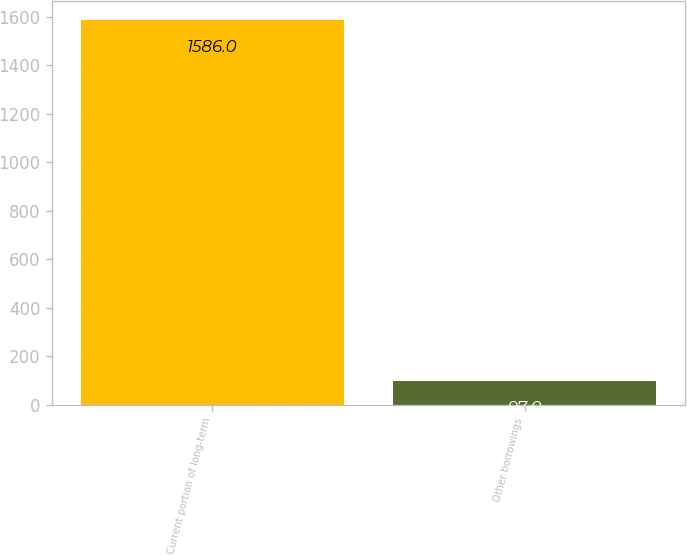Convert chart to OTSL. <chart><loc_0><loc_0><loc_500><loc_500><bar_chart><fcel>Current portion of long-term<fcel>Other borrowings<nl><fcel>1586<fcel>97<nl></chart> 